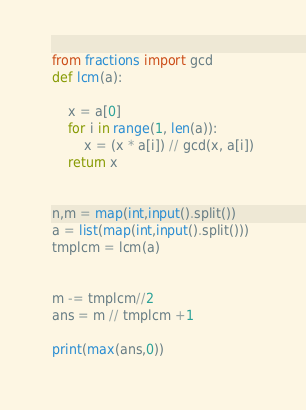Convert code to text. <code><loc_0><loc_0><loc_500><loc_500><_Python_>from fractions import gcd
def lcm(a):

    x = a[0]
    for i in range(1, len(a)):
        x = (x * a[i]) // gcd(x, a[i])
    return x


n,m = map(int,input().split())
a = list(map(int,input().split()))
tmplcm = lcm(a)


m -= tmplcm//2
ans = m // tmplcm +1

print(max(ans,0))</code> 